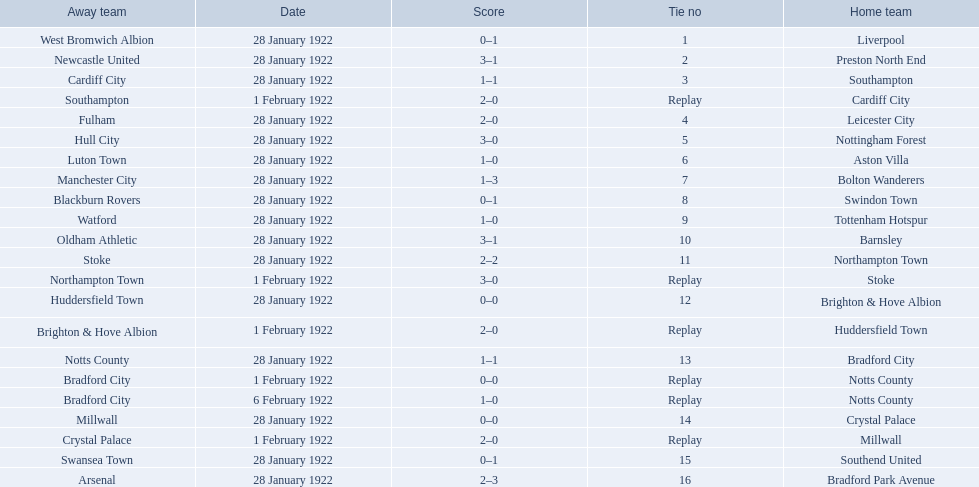What are all of the home teams? Liverpool, Preston North End, Southampton, Cardiff City, Leicester City, Nottingham Forest, Aston Villa, Bolton Wanderers, Swindon Town, Tottenham Hotspur, Barnsley, Northampton Town, Stoke, Brighton & Hove Albion, Huddersfield Town, Bradford City, Notts County, Notts County, Crystal Palace, Millwall, Southend United, Bradford Park Avenue. What were the scores? 0–1, 3–1, 1–1, 2–0, 2–0, 3–0, 1–0, 1–3, 0–1, 1–0, 3–1, 2–2, 3–0, 0–0, 2–0, 1–1, 0–0, 1–0, 0–0, 2–0, 0–1, 2–3. On which dates did they play? 28 January 1922, 28 January 1922, 28 January 1922, 1 February 1922, 28 January 1922, 28 January 1922, 28 January 1922, 28 January 1922, 28 January 1922, 28 January 1922, 28 January 1922, 28 January 1922, 1 February 1922, 28 January 1922, 1 February 1922, 28 January 1922, 1 February 1922, 6 February 1922, 28 January 1922, 1 February 1922, 28 January 1922, 28 January 1922. Which teams played on 28 january 1922? Liverpool, Preston North End, Southampton, Leicester City, Nottingham Forest, Aston Villa, Bolton Wanderers, Swindon Town, Tottenham Hotspur, Barnsley, Northampton Town, Brighton & Hove Albion, Bradford City, Crystal Palace, Southend United, Bradford Park Avenue. Of those, which scored the same as aston villa? Tottenham Hotspur. 